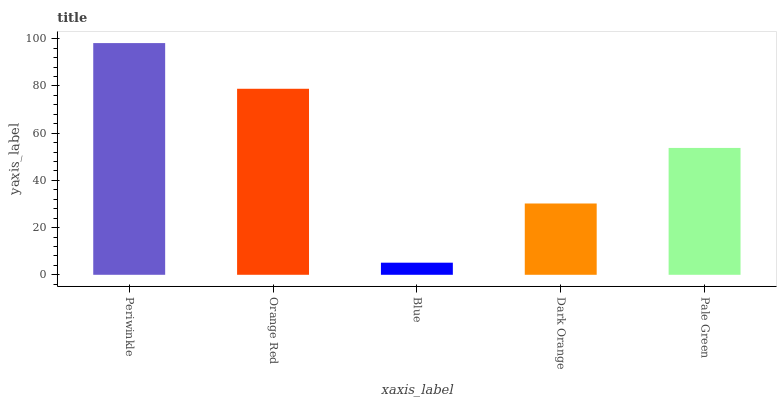Is Orange Red the minimum?
Answer yes or no. No. Is Orange Red the maximum?
Answer yes or no. No. Is Periwinkle greater than Orange Red?
Answer yes or no. Yes. Is Orange Red less than Periwinkle?
Answer yes or no. Yes. Is Orange Red greater than Periwinkle?
Answer yes or no. No. Is Periwinkle less than Orange Red?
Answer yes or no. No. Is Pale Green the high median?
Answer yes or no. Yes. Is Pale Green the low median?
Answer yes or no. Yes. Is Dark Orange the high median?
Answer yes or no. No. Is Orange Red the low median?
Answer yes or no. No. 